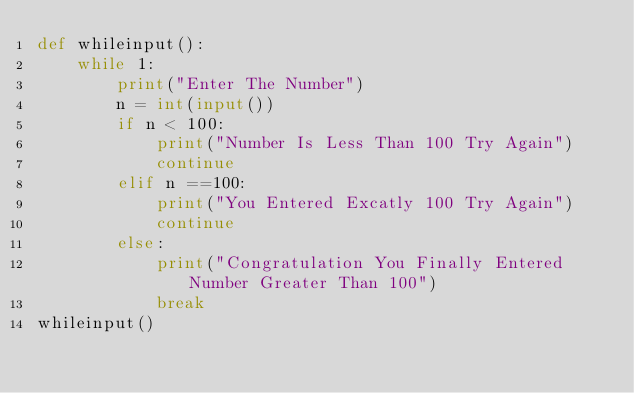<code> <loc_0><loc_0><loc_500><loc_500><_Python_>def whileinput():
    while 1:
        print("Enter The Number")
        n = int(input())
        if n < 100:
            print("Number Is Less Than 100 Try Again")
            continue
        elif n ==100:
            print("You Entered Excatly 100 Try Again")
            continue
        else:
            print("Congratulation You Finally Entered Number Greater Than 100")
            break
whileinput()

</code> 